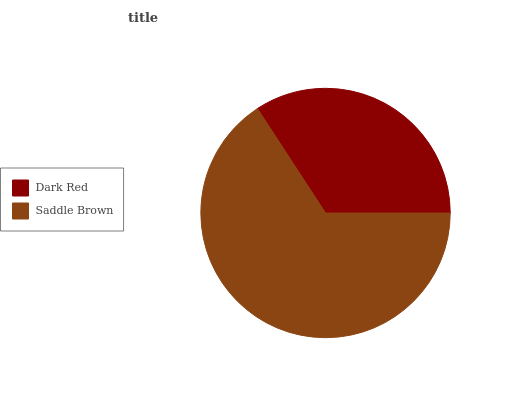Is Dark Red the minimum?
Answer yes or no. Yes. Is Saddle Brown the maximum?
Answer yes or no. Yes. Is Saddle Brown the minimum?
Answer yes or no. No. Is Saddle Brown greater than Dark Red?
Answer yes or no. Yes. Is Dark Red less than Saddle Brown?
Answer yes or no. Yes. Is Dark Red greater than Saddle Brown?
Answer yes or no. No. Is Saddle Brown less than Dark Red?
Answer yes or no. No. Is Saddle Brown the high median?
Answer yes or no. Yes. Is Dark Red the low median?
Answer yes or no. Yes. Is Dark Red the high median?
Answer yes or no. No. Is Saddle Brown the low median?
Answer yes or no. No. 